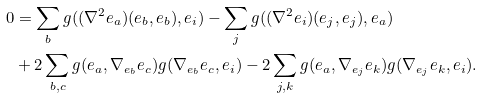Convert formula to latex. <formula><loc_0><loc_0><loc_500><loc_500>0 & = \sum _ { b } g ( ( \nabla ^ { 2 } e _ { a } ) ( e _ { b } , e _ { b } ) , e _ { i } ) - \sum _ { j } g ( ( \nabla ^ { 2 } e _ { i } ) ( e _ { j } , e _ { j } ) , e _ { a } ) \\ & + 2 \sum _ { b , c } g ( e _ { a } , \nabla _ { e _ { b } } e _ { c } ) g ( \nabla _ { e _ { b } } e _ { c } , e _ { i } ) - 2 \sum _ { j , k } g ( e _ { a } , \nabla _ { e _ { j } } e _ { k } ) g ( \nabla _ { e _ { j } } e _ { k } , e _ { i } ) .</formula> 